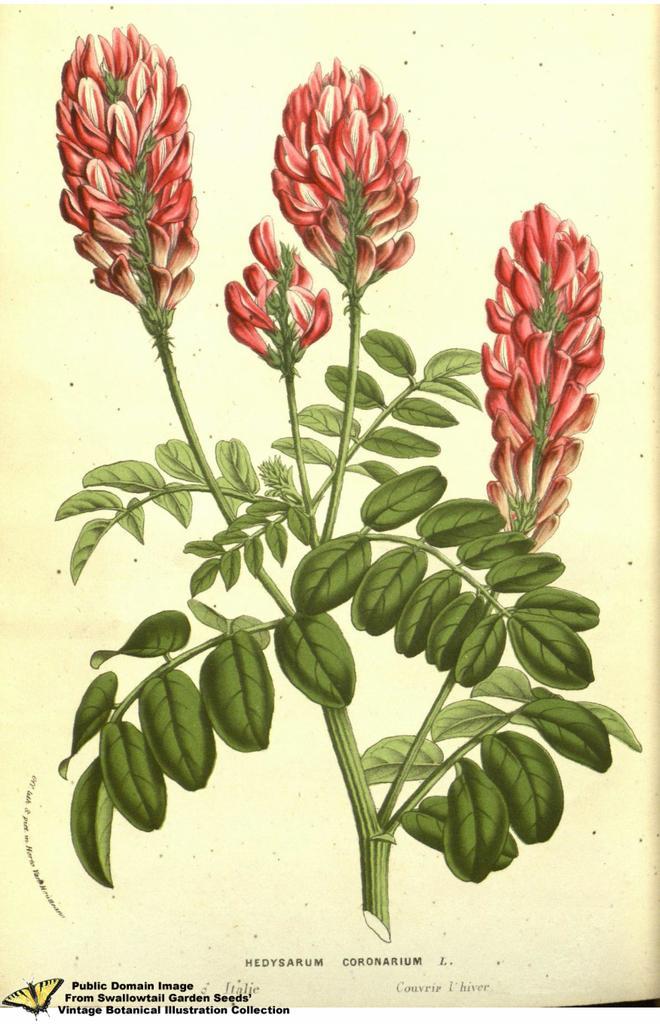Describe this image in one or two sentences. In this image I can see a painting of a flowering plant and a text. This image looks like a painting. 